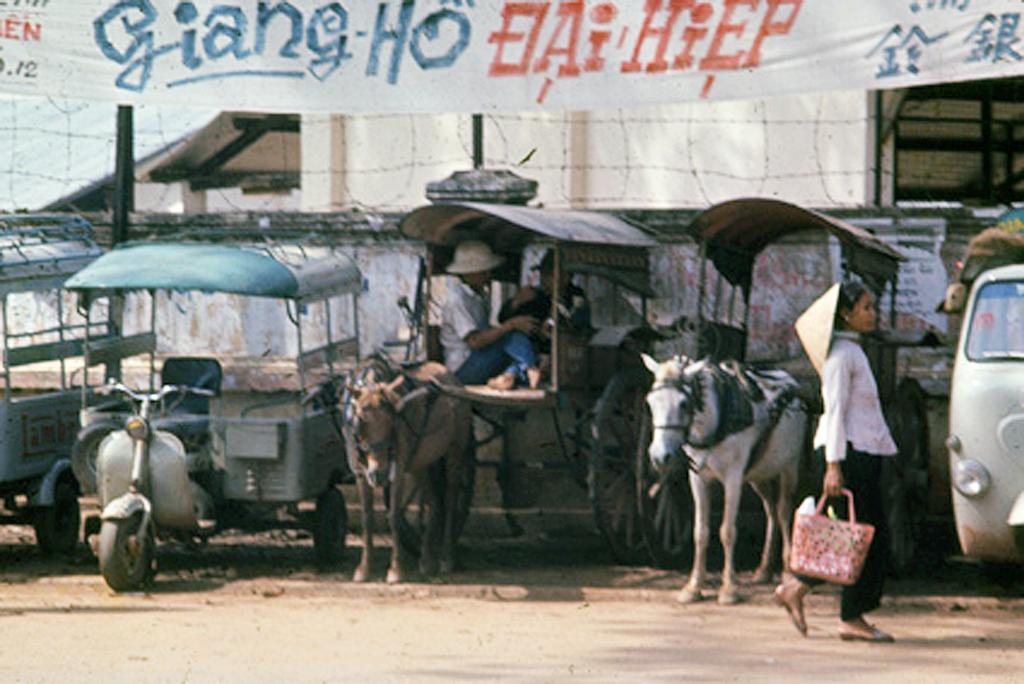How would you summarize this image in a sentence or two? In this image i can see 2 persons sitting in a cart which is tied to a horse, and to the left corner i can see a vehicle which is a 3 wheeler, and to the right side of the image i can see a woman walking, holding a pink bag in her hand, and in the background i can see a banner which is tied to the railing. 